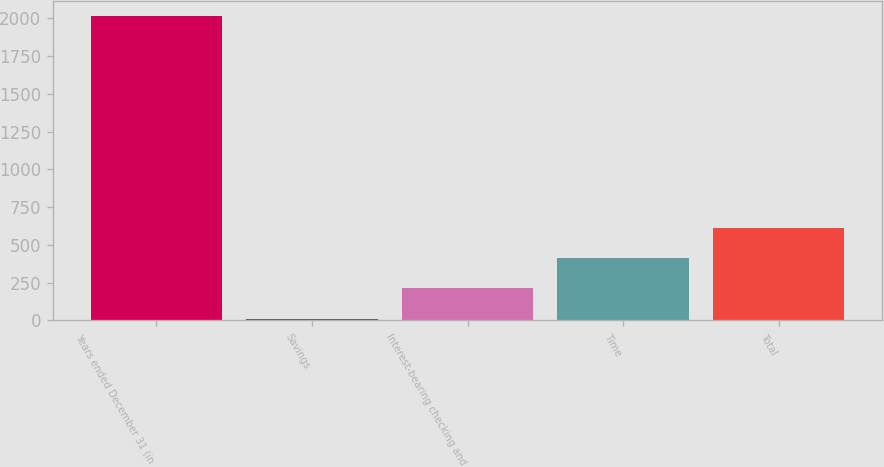<chart> <loc_0><loc_0><loc_500><loc_500><bar_chart><fcel>Years ended December 31 (in<fcel>Savings<fcel>Interest-bearing checking and<fcel>Time<fcel>Total<nl><fcel>2014<fcel>10.9<fcel>211.21<fcel>411.52<fcel>611.83<nl></chart> 